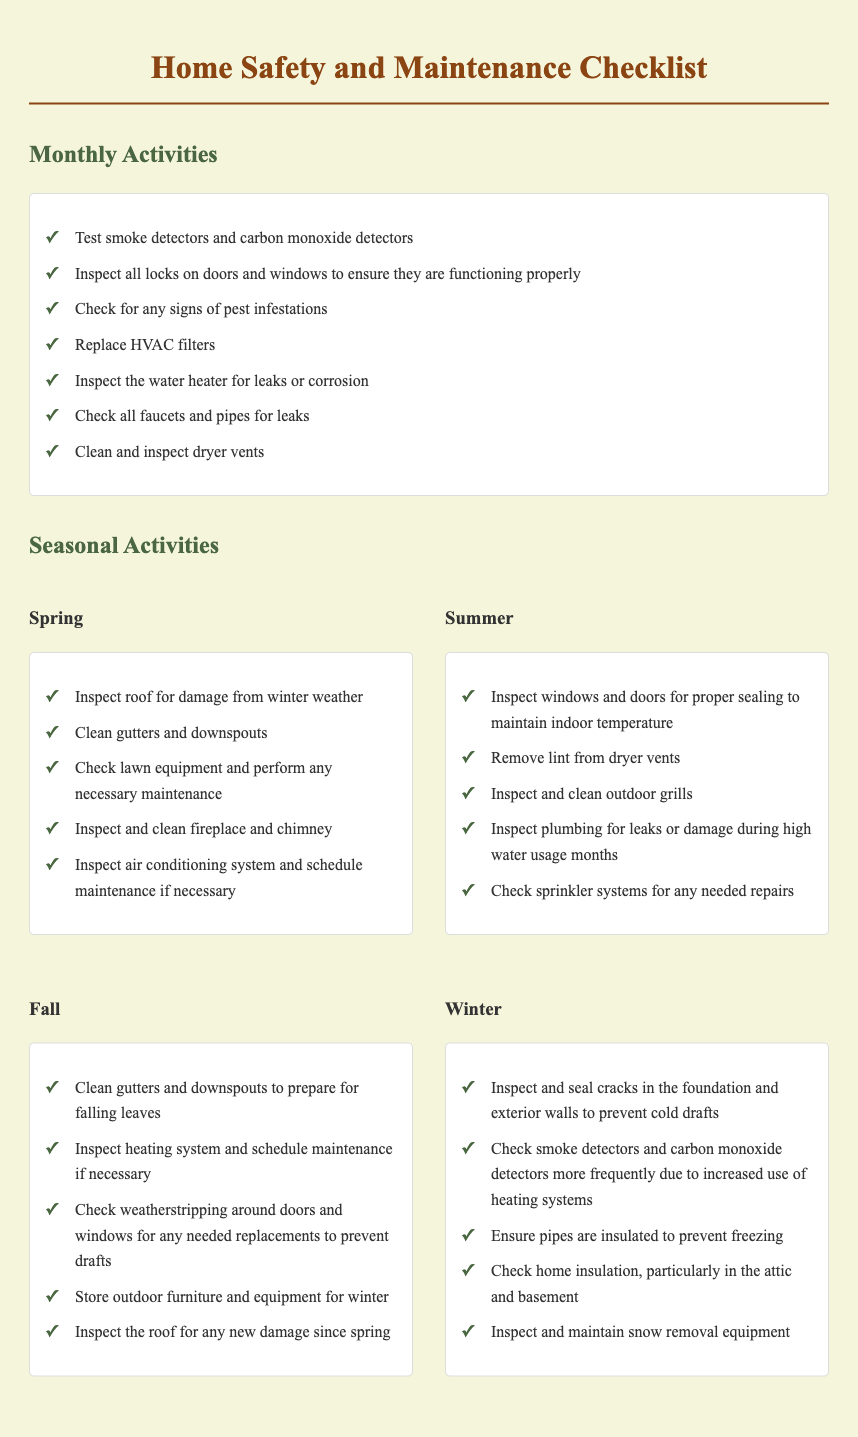What is the title of the document? The title of the document is the heading displayed at the top of the page, which is "Home Safety and Maintenance Checklist."
Answer: Home Safety and Maintenance Checklist How many monthly activities are listed? The document lists seven monthly activities in the specific section for monthly activities.
Answer: 7 Which seasonal activity involves checking the air conditioning system? The activity can be found under the seasonal activities for spring, which mentions inspecting the air conditioning system.
Answer: Inspect and clean air conditioning system What should be done to the gutters in the fall? The fall section includes a task to clean gutters and downspouts to prepare for falling leaves.
Answer: Clean gutters and downspouts Which type of equipment should be inspected and maintained in winter? The winter section specifies the inspection and maintenance of snow removal equipment.
Answer: Snow removal equipment How often should smoke detectors be checked according to the winter activities? The winter activities suggest checking smoke detectors more frequently due to heating system use.
Answer: More frequently Which season includes checking lawn equipment? The checklist indicates that checking lawn equipment is part of the spring activities.
Answer: Spring What is one of the activities listed for summer? The summer activities include inspecting windows and doors for proper sealing to maintain indoor temperature.
Answer: Inspect windows and doors for proper sealing 